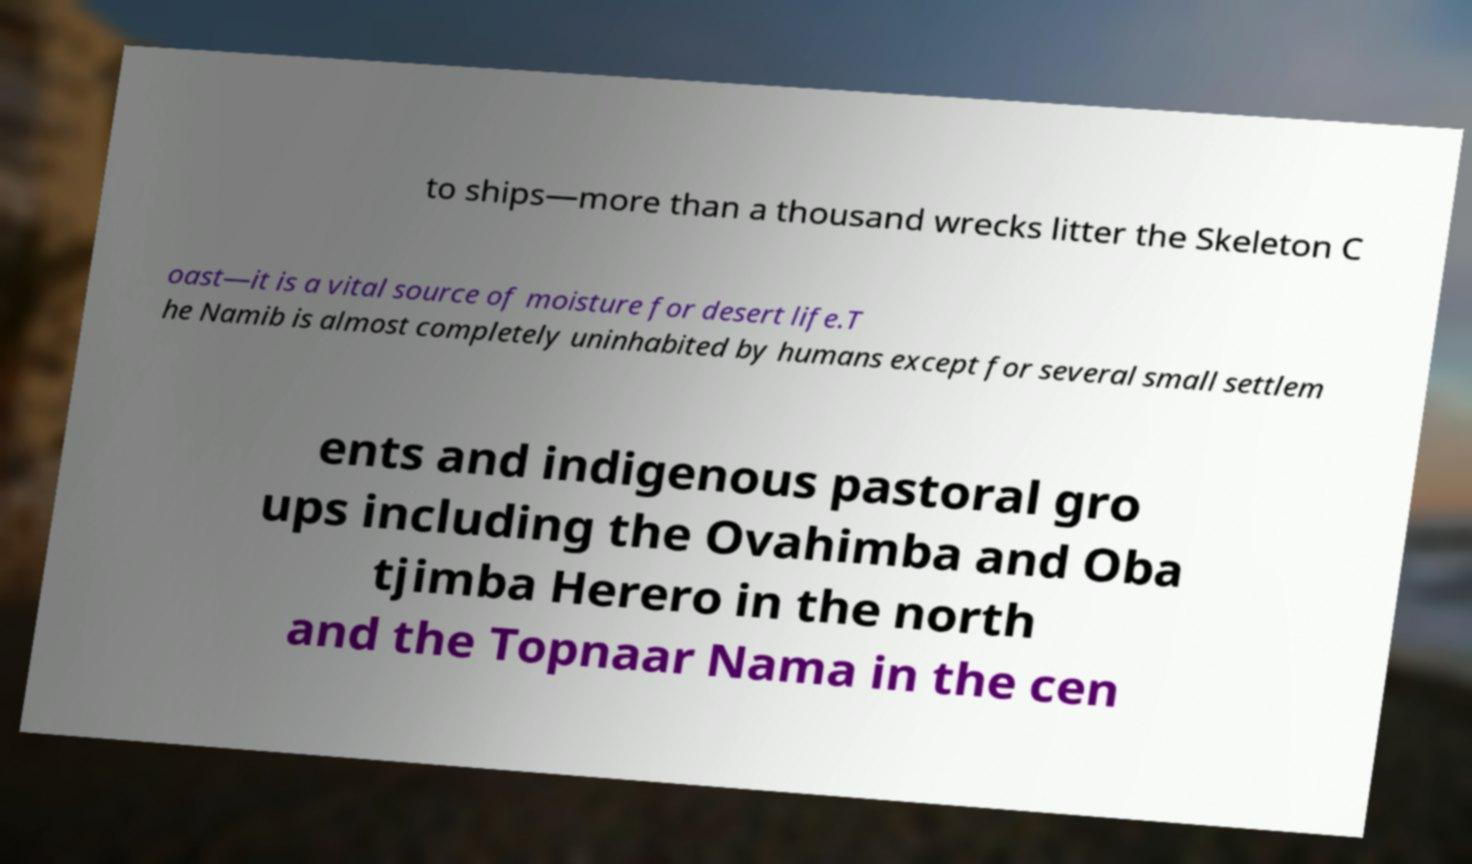What messages or text are displayed in this image? I need them in a readable, typed format. to ships—more than a thousand wrecks litter the Skeleton C oast—it is a vital source of moisture for desert life.T he Namib is almost completely uninhabited by humans except for several small settlem ents and indigenous pastoral gro ups including the Ovahimba and Oba tjimba Herero in the north and the Topnaar Nama in the cen 